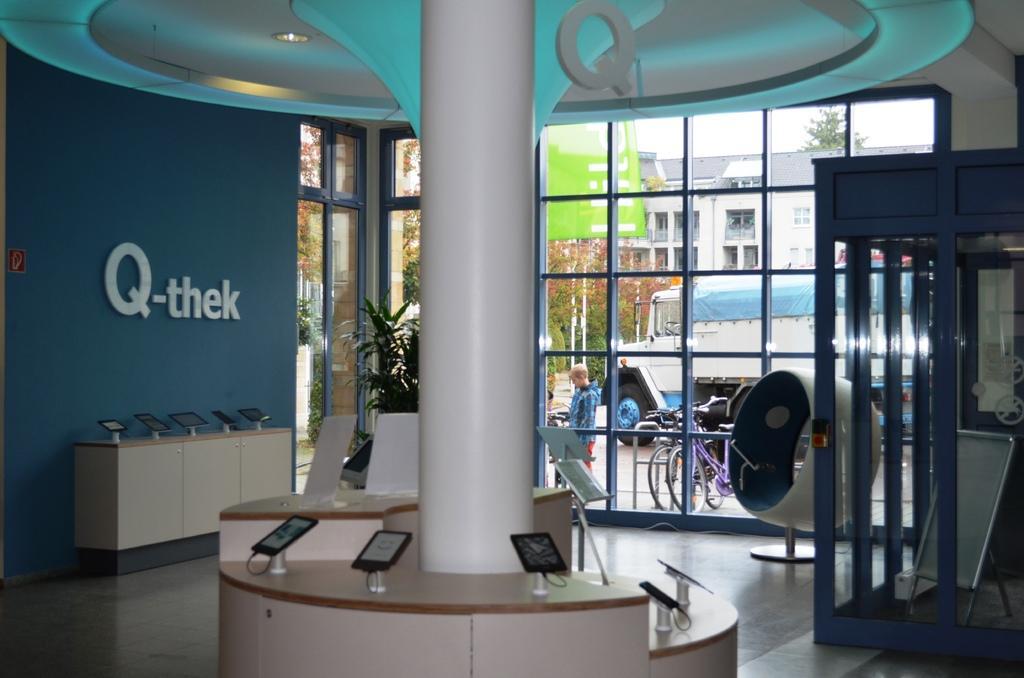How would you summarize this image in a sentence or two? In this picture we can see a pillar and some objects on the cabinets and on the pillar, it looks like a chair, board and some objects. On the left side of the pillar there is a wall with a name board. Behind the pillar there is a houseplant and glass windows. Through the windows we can see the bicycles, a person, a vehicle on the path. Behind the vehicles there are trees, buildings and the sky. 